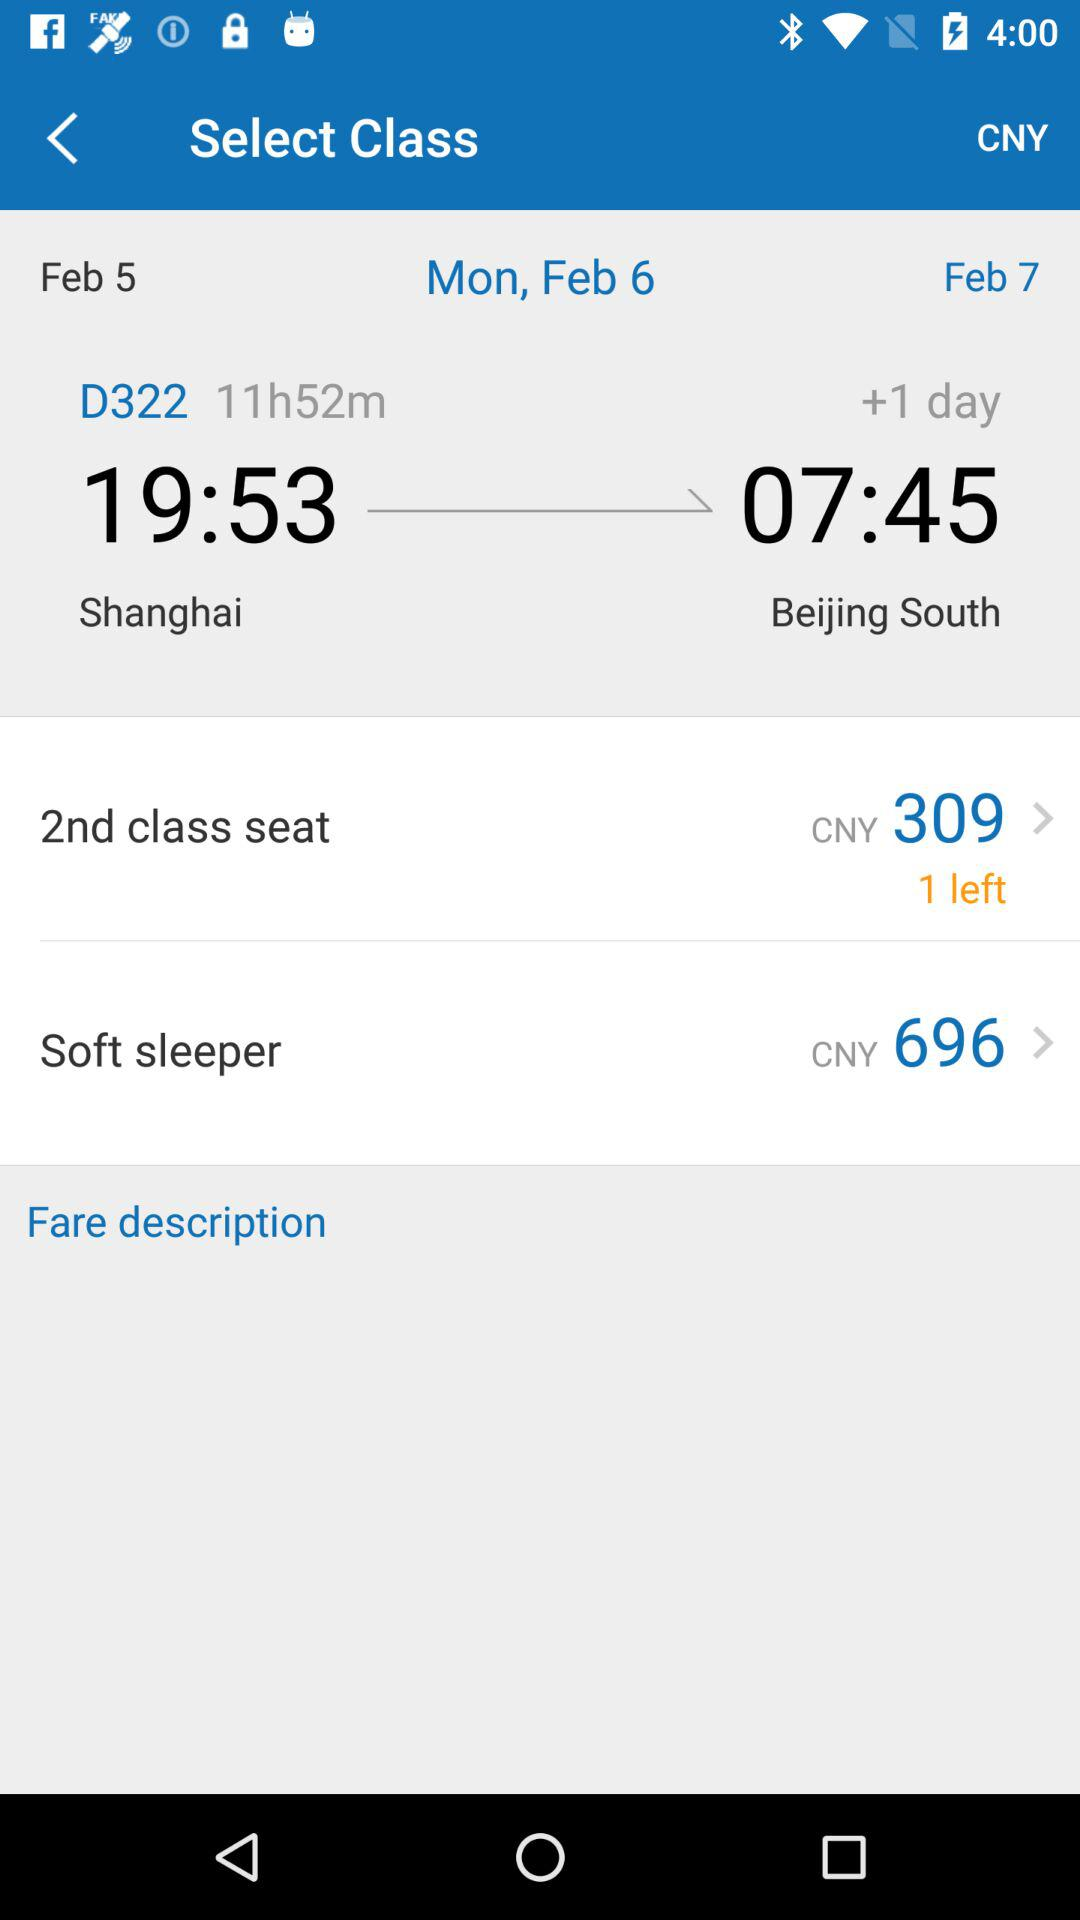How many seats are left in the "2nd class seat" category? There is 1 seat left in the "2nd class seat" category. 